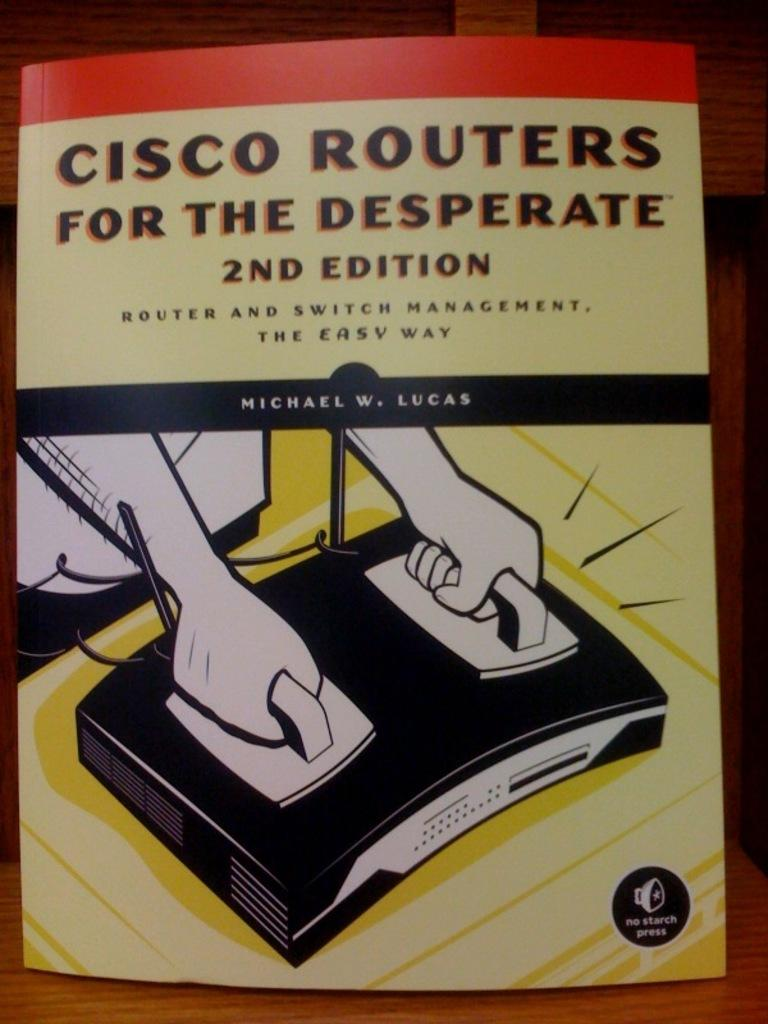<image>
Summarize the visual content of the image. An educational computer manual is a publishing effort from No Starch Press. 